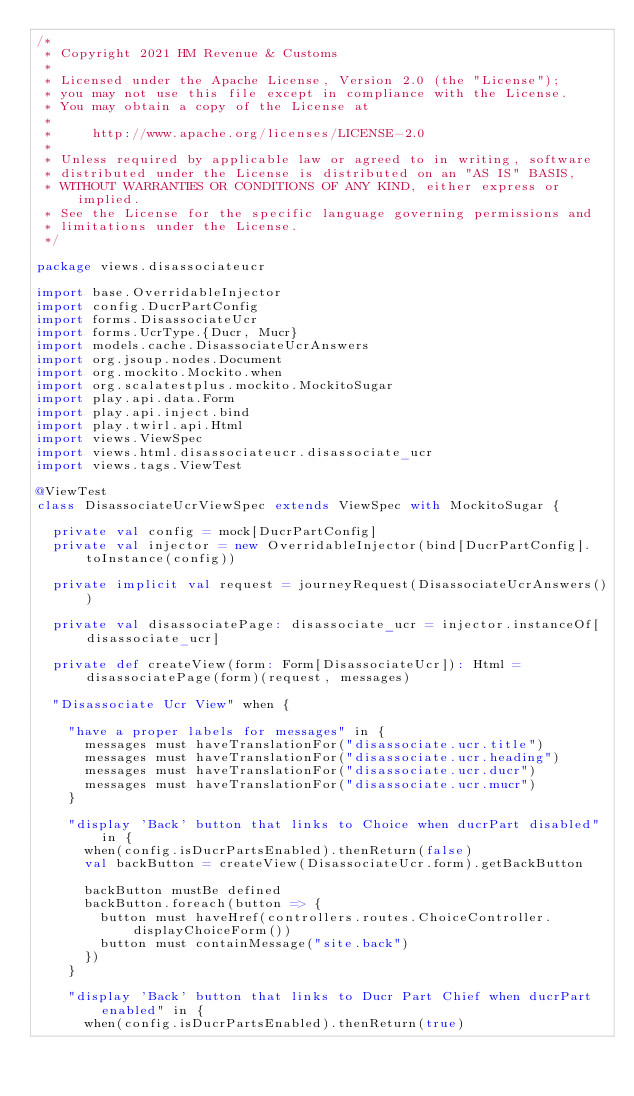<code> <loc_0><loc_0><loc_500><loc_500><_Scala_>/*
 * Copyright 2021 HM Revenue & Customs
 *
 * Licensed under the Apache License, Version 2.0 (the "License");
 * you may not use this file except in compliance with the License.
 * You may obtain a copy of the License at
 *
 *     http://www.apache.org/licenses/LICENSE-2.0
 *
 * Unless required by applicable law or agreed to in writing, software
 * distributed under the License is distributed on an "AS IS" BASIS,
 * WITHOUT WARRANTIES OR CONDITIONS OF ANY KIND, either express or implied.
 * See the License for the specific language governing permissions and
 * limitations under the License.
 */

package views.disassociateucr

import base.OverridableInjector
import config.DucrPartConfig
import forms.DisassociateUcr
import forms.UcrType.{Ducr, Mucr}
import models.cache.DisassociateUcrAnswers
import org.jsoup.nodes.Document
import org.mockito.Mockito.when
import org.scalatestplus.mockito.MockitoSugar
import play.api.data.Form
import play.api.inject.bind
import play.twirl.api.Html
import views.ViewSpec
import views.html.disassociateucr.disassociate_ucr
import views.tags.ViewTest

@ViewTest
class DisassociateUcrViewSpec extends ViewSpec with MockitoSugar {

  private val config = mock[DucrPartConfig]
  private val injector = new OverridableInjector(bind[DucrPartConfig].toInstance(config))

  private implicit val request = journeyRequest(DisassociateUcrAnswers())

  private val disassociatePage: disassociate_ucr = injector.instanceOf[disassociate_ucr]

  private def createView(form: Form[DisassociateUcr]): Html = disassociatePage(form)(request, messages)

  "Disassociate Ucr View" when {

    "have a proper labels for messages" in {
      messages must haveTranslationFor("disassociate.ucr.title")
      messages must haveTranslationFor("disassociate.ucr.heading")
      messages must haveTranslationFor("disassociate.ucr.ducr")
      messages must haveTranslationFor("disassociate.ucr.mucr")
    }

    "display 'Back' button that links to Choice when ducrPart disabled" in {
      when(config.isDucrPartsEnabled).thenReturn(false)
      val backButton = createView(DisassociateUcr.form).getBackButton

      backButton mustBe defined
      backButton.foreach(button => {
        button must haveHref(controllers.routes.ChoiceController.displayChoiceForm())
        button must containMessage("site.back")
      })
    }

    "display 'Back' button that links to Ducr Part Chief when ducrPart enabled" in {
      when(config.isDucrPartsEnabled).thenReturn(true)</code> 